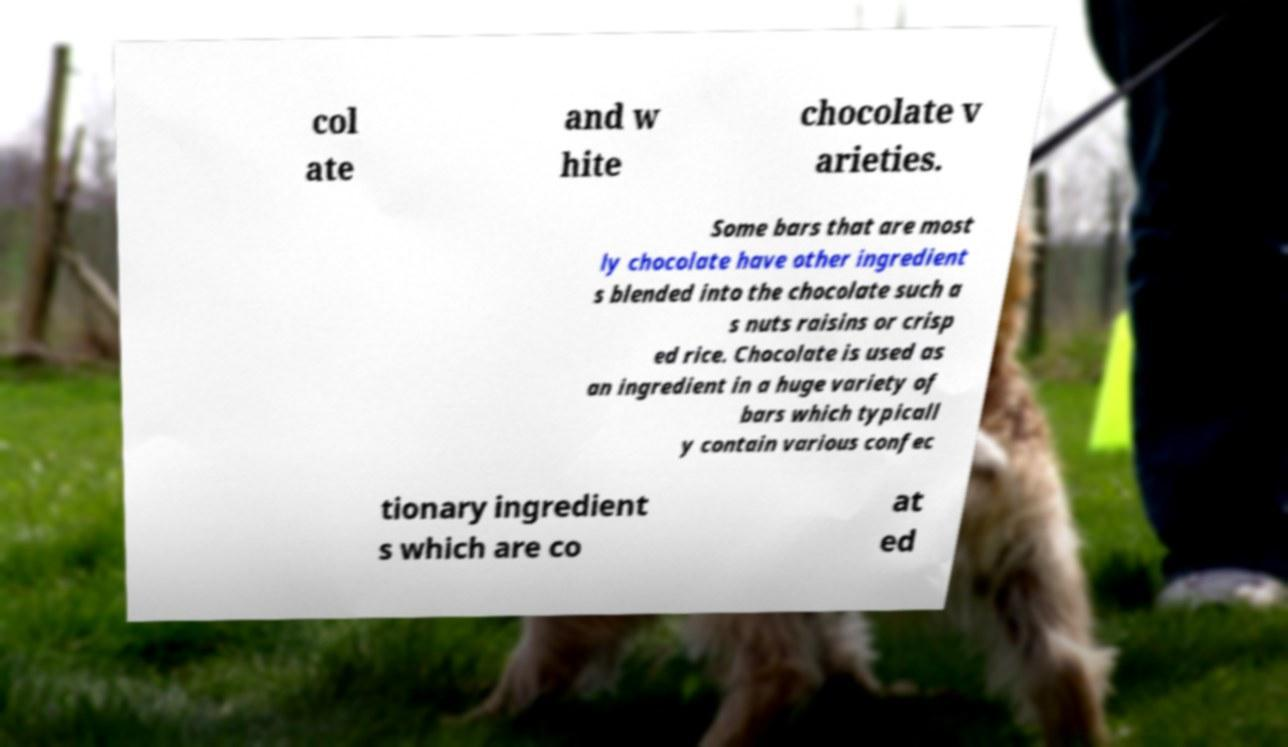Please identify and transcribe the text found in this image. col ate and w hite chocolate v arieties. Some bars that are most ly chocolate have other ingredient s blended into the chocolate such a s nuts raisins or crisp ed rice. Chocolate is used as an ingredient in a huge variety of bars which typicall y contain various confec tionary ingredient s which are co at ed 